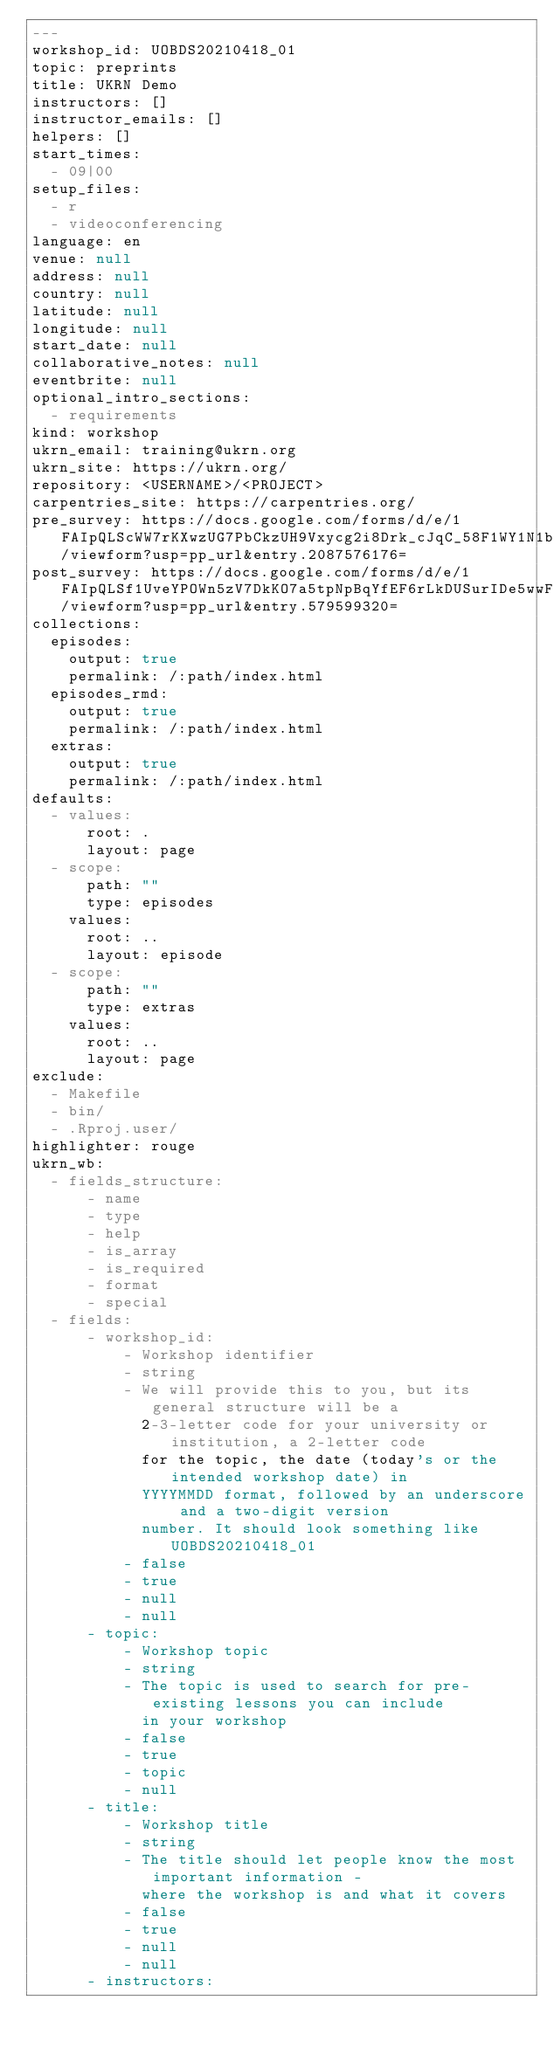Convert code to text. <code><loc_0><loc_0><loc_500><loc_500><_YAML_>---
workshop_id: UOBDS20210418_01
topic: preprints
title: UKRN Demo
instructors: []
instructor_emails: []
helpers: []
start_times:
  - 09|00
setup_files:
  - r
  - videoconferencing
language: en
venue: null
address: null
country: null
latitude: null
longitude: null
start_date: null
collaborative_notes: null
eventbrite: null
optional_intro_sections:
  - requirements
kind: workshop
ukrn_email: training@ukrn.org
ukrn_site: https://ukrn.org/
repository: <USERNAME>/<PROJECT>
carpentries_site: https://carpentries.org/
pre_survey: https://docs.google.com/forms/d/e/1FAIpQLScWW7rKXwzUG7PbCkzUH9Vxycg2i8Drk_cJqC_58F1WY1N1bA/viewform?usp=pp_url&entry.2087576176=
post_survey: https://docs.google.com/forms/d/e/1FAIpQLSf1UveYPOWn5zV7DkKO7a5tpNpBqYfEF6rLkDUSurIDe5wwFg/viewform?usp=pp_url&entry.579599320=
collections:
  episodes:
    output: true
    permalink: /:path/index.html
  episodes_rmd:
    output: true
    permalink: /:path/index.html
  extras:
    output: true
    permalink: /:path/index.html
defaults:
  - values:
      root: .
      layout: page
  - scope:
      path: ""
      type: episodes
    values:
      root: ..
      layout: episode
  - scope:
      path: ""
      type: extras
    values:
      root: ..
      layout: page
exclude:
  - Makefile
  - bin/
  - .Rproj.user/
highlighter: rouge
ukrn_wb:
  - fields_structure:
      - name
      - type
      - help
      - is_array
      - is_required
      - format
      - special
  - fields:
      - workshop_id:
          - Workshop identifier
          - string
          - We will provide this to you, but its general structure will be a
            2-3-letter code for your university or institution, a 2-letter code
            for the topic, the date (today's or the intended workshop date) in
            YYYYMMDD format, followed by an underscore and a two-digit version
            number. It should look something like UOBDS20210418_01
          - false
          - true
          - null
          - null
      - topic:
          - Workshop topic
          - string
          - The topic is used to search for pre-existing lessons you can include
            in your workshop
          - false
          - true
          - topic
          - null
      - title:
          - Workshop title
          - string
          - The title should let people know the most important information -
            where the workshop is and what it covers
          - false
          - true
          - null
          - null
      - instructors:</code> 